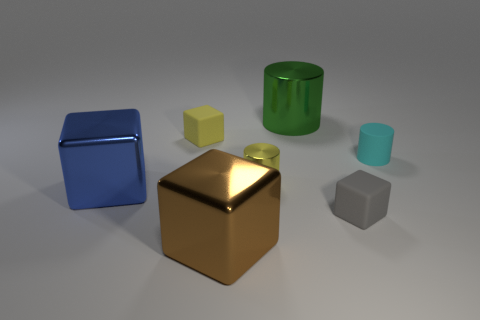There is another tiny thing that is the same shape as the yellow metallic object; what is it made of?
Keep it short and to the point. Rubber. How many matte objects have the same color as the small metallic cylinder?
Ensure brevity in your answer.  1. There is a yellow cylinder that is made of the same material as the blue block; what is its size?
Give a very brief answer. Small. What number of brown objects are large cylinders or blocks?
Provide a short and direct response. 1. How many cubes are behind the matte cube that is in front of the blue block?
Offer a terse response. 2. Are there more metallic blocks to the left of the small gray matte block than metallic cubes that are behind the small cyan thing?
Offer a terse response. Yes. What is the small cyan object made of?
Offer a terse response. Rubber. Is there a thing of the same size as the cyan rubber cylinder?
Give a very brief answer. Yes. There is a blue block that is the same size as the brown object; what material is it?
Provide a short and direct response. Metal. How many small yellow shiny objects are there?
Offer a terse response. 1. 